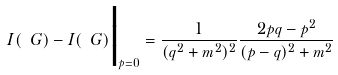Convert formula to latex. <formula><loc_0><loc_0><loc_500><loc_500>I ( \ G ) - I ( \ G ) \Big | _ { p = 0 } & = \frac { 1 } { ( q ^ { 2 } + m ^ { 2 } ) ^ { 2 } } \frac { 2 p q - p ^ { 2 } } { ( p - q ) ^ { 2 } + m ^ { 2 } }</formula> 